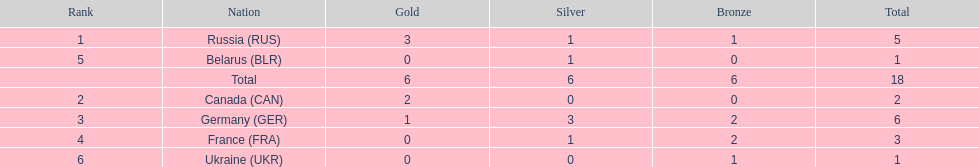What were all the countries that won biathlon medals? Russia (RUS), Canada (CAN), Germany (GER), France (FRA), Belarus (BLR), Ukraine (UKR). What were their medal counts? 5, 2, 6, 3, 1, 1. Of these, which is the largest number of medals? 6. Which country won this number of medals? Germany (GER). 